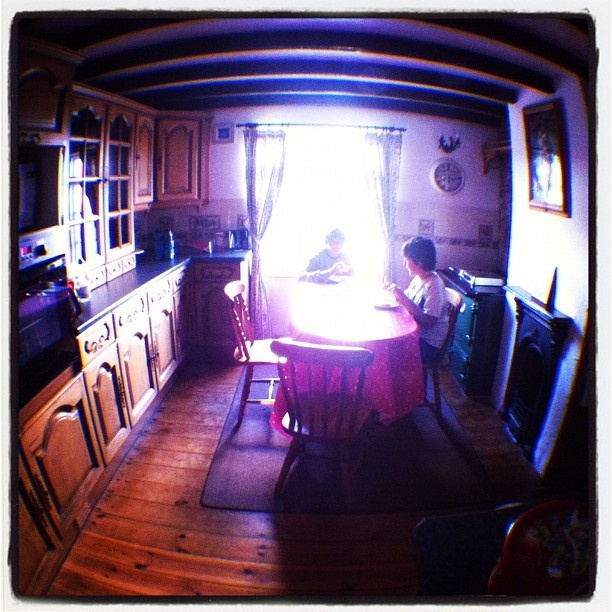Describe the objects in this image and their specific colors. I can see chair in white, purple, and navy tones, dining table in white and violet tones, people in white, blue, navy, lavender, and darkblue tones, chair in white, purple, and violet tones, and people in white and lavender tones in this image. 